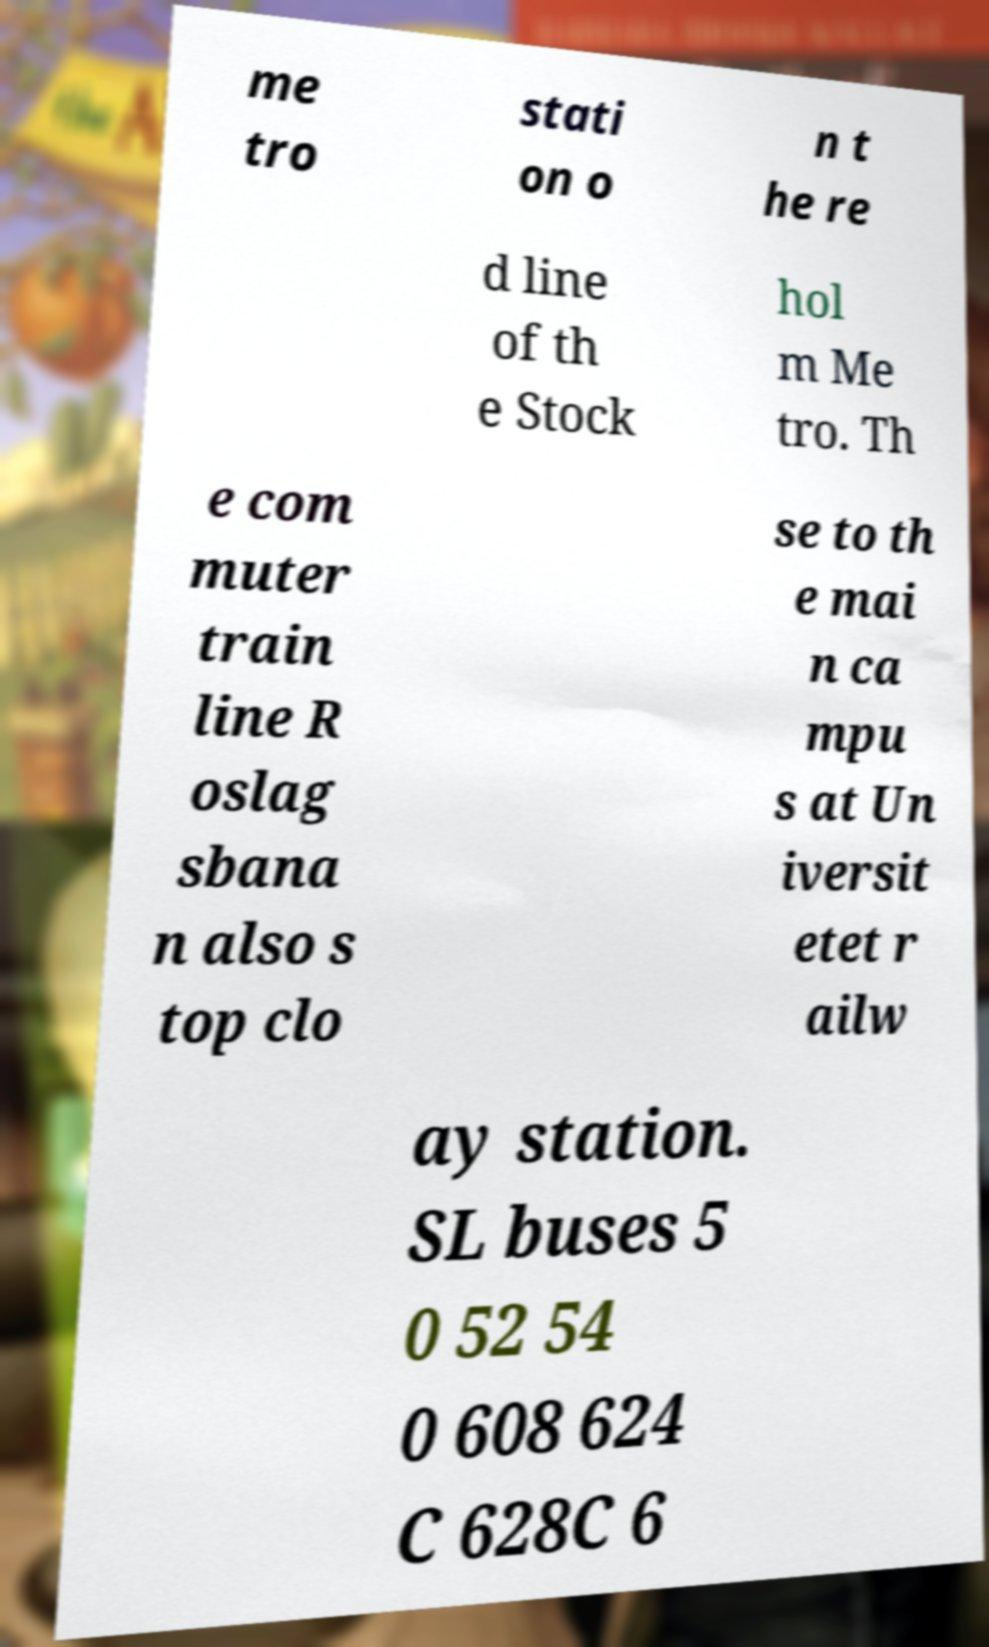Can you read and provide the text displayed in the image?This photo seems to have some interesting text. Can you extract and type it out for me? me tro stati on o n t he re d line of th e Stock hol m Me tro. Th e com muter train line R oslag sbana n also s top clo se to th e mai n ca mpu s at Un iversit etet r ailw ay station. SL buses 5 0 52 54 0 608 624 C 628C 6 